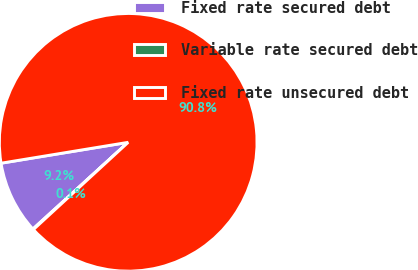<chart> <loc_0><loc_0><loc_500><loc_500><pie_chart><fcel>Fixed rate secured debt<fcel>Variable rate secured debt<fcel>Fixed rate unsecured debt<nl><fcel>9.16%<fcel>0.09%<fcel>90.75%<nl></chart> 